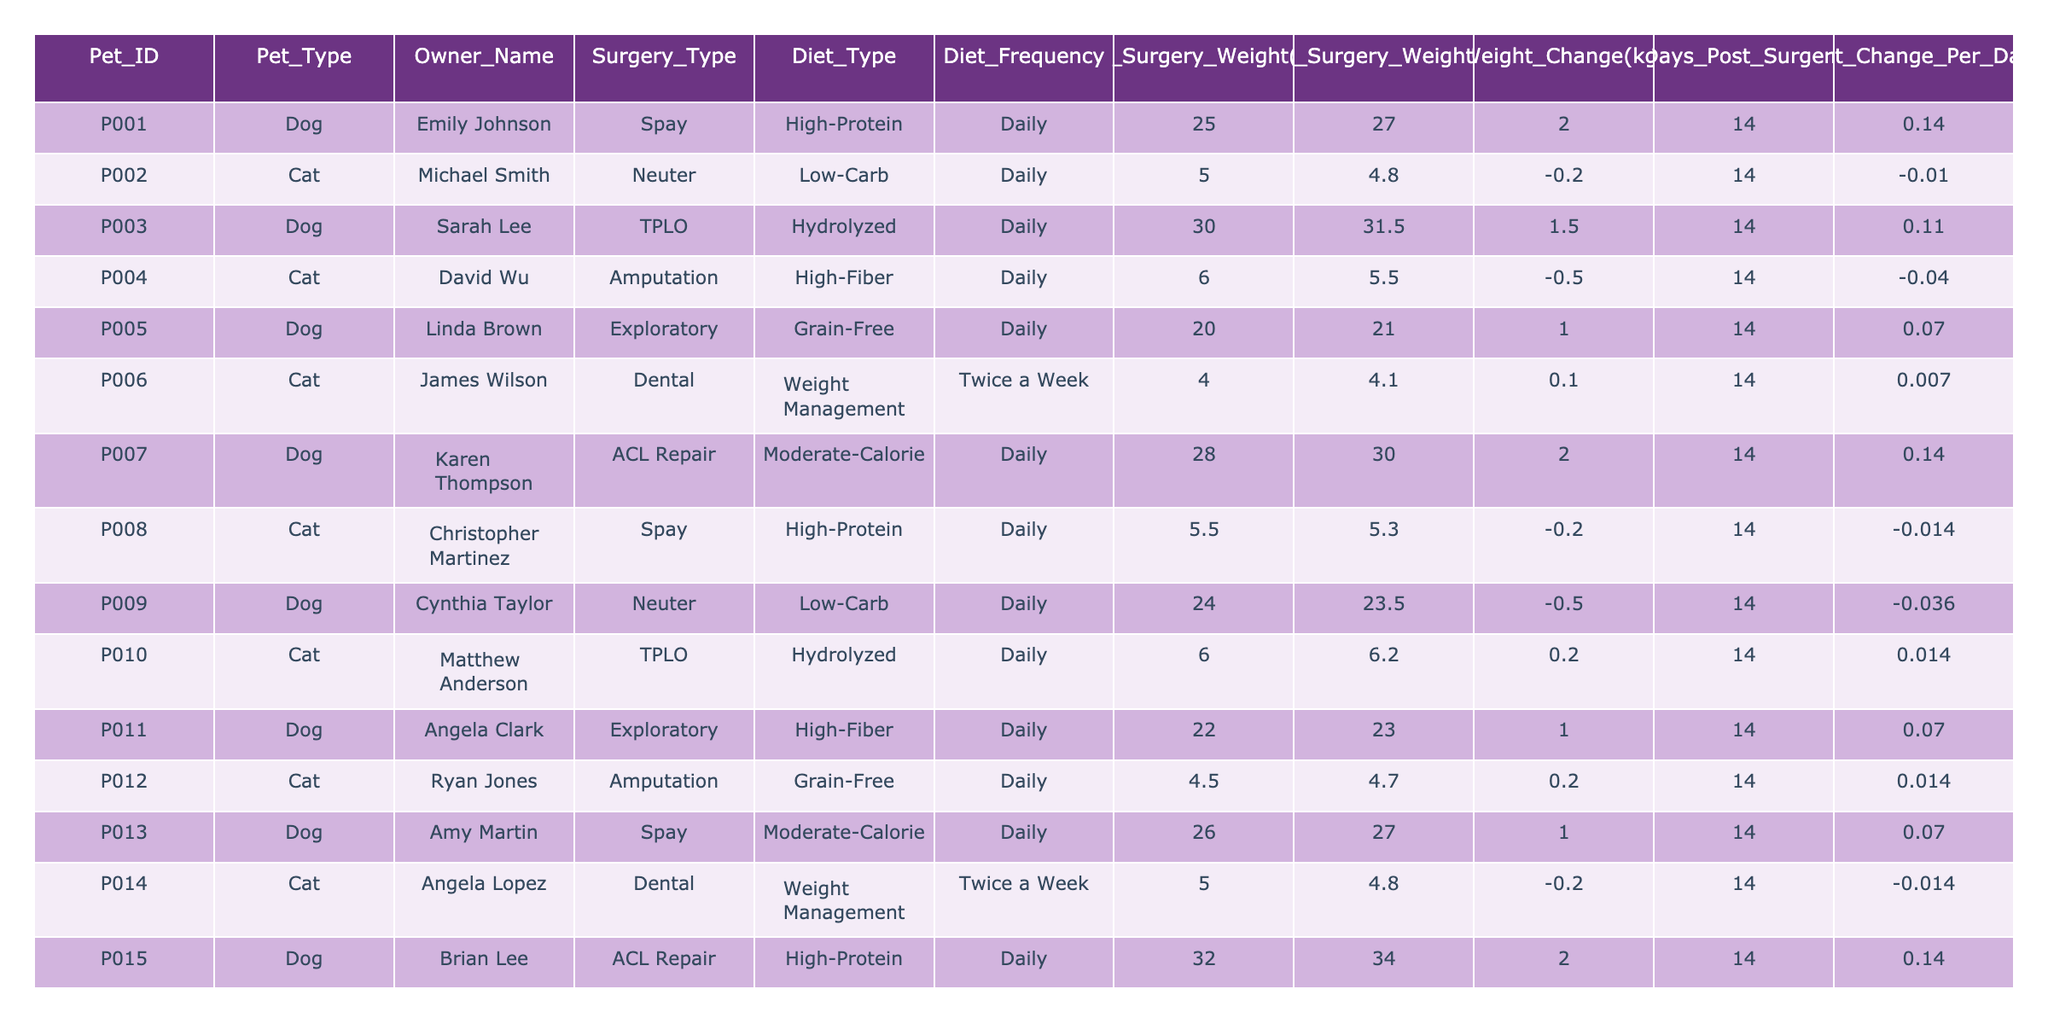What is the weight change for Pet ID P005? For Pet ID P005, the "Weight Change(kg)" column shows a value of 1.
Answer: 1 How many pets lost weight after their surgery? By reviewing the "Weight Change(kg)" column, we see that pets P002, P004, P008, P009, and P014 have negative weight changes, indicating they lost weight. This counts to 5 pets.
Answer: 5 What was the post-surgery weight of the cat that underwent a dental procedure? In the table, we look for the entry with "Surgery_Type" as "Dental." The post-surgery weight for cat P006 is listed as 4.1.
Answer: 4.1 What diet type was associated with the highest average weight change? We calculate the average weight change for each diet type: High-Protein (1.0), Low-Carb (-0.25), Hydrolyzed (0.35), High-Fiber (0.5), Grain-Free (0.1), Moderate-Calorie (1.5), and Weight Management (0.15). The highest average is for the Moderate-Calorie diet, which is 1.5.
Answer: Moderate-Calorie Is there a pet that had no weight change after surgery? Looking through the "Weight Change(kg)" column, we see that none of the entries are zero. Hence, it is not true that there is a pet with no weight change.
Answer: No Which pet had the most significant weight gain per day after surgery? Pet ID P001 and Pet ID P007 both had a weight change of 2 kg in 14 days, yielding a weight change per day of 0.14 kg. There are no other pets with a higher per-day rate.
Answer: P001 and P007 What is the average weight change for all dogs in the table? First, we gather the weight changes for the dogs: P001 (2), P003 (1.5), P005 (1), P007 (2), P009 (-0.5), P011 (1), P013 (1), P015 (2). Adding these gives 2 + 1.5 + 1 + 2 - 0.5 + 1 + 1 + 2 = 10. This is divided by 8 (the number of dogs), yielding an average of 1.25.
Answer: 1.25 What is the minimum weight change recorded among cats in the study? Looking through the "Weight Change(kg)" values for cats: P002 (-0.2), P004 (-0.5), P006 (0.1), P008 (-0.2), P010 (0.2), P012 (0.2), and P014 (-0.2). The minimum value is -0.5.
Answer: -0.5 How many days post-surgery did the lowest weight loss pet have? Pet P004 lost the most weight (-0.5 kg), and the days post-surgery listed for this pet is 14 days, confirming the duration.
Answer: 14 Which surgery type had pets that gained weight? Reviewing the data, pets that gained weight were associated with the surgery types Spay (P001, P013), TPLO (P003), and both ACL Repairs (P007, P015). This highlights Spay and ACL Repair as surgery types leading to weight gain.
Answer: Spay and ACL Repair 